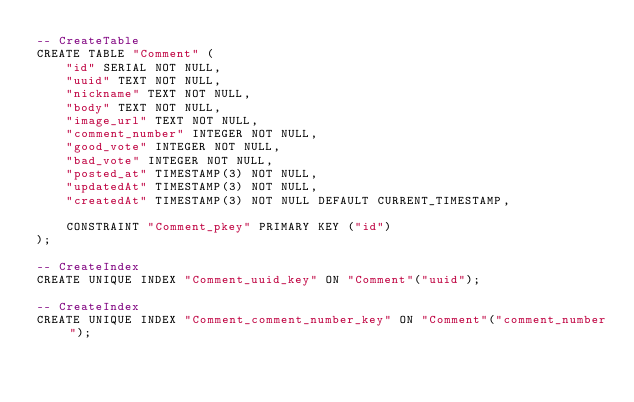Convert code to text. <code><loc_0><loc_0><loc_500><loc_500><_SQL_>-- CreateTable
CREATE TABLE "Comment" (
    "id" SERIAL NOT NULL,
    "uuid" TEXT NOT NULL,
    "nickname" TEXT NOT NULL,
    "body" TEXT NOT NULL,
    "image_url" TEXT NOT NULL,
    "comment_number" INTEGER NOT NULL,
    "good_vote" INTEGER NOT NULL,
    "bad_vote" INTEGER NOT NULL,
    "posted_at" TIMESTAMP(3) NOT NULL,
    "updatedAt" TIMESTAMP(3) NOT NULL,
    "createdAt" TIMESTAMP(3) NOT NULL DEFAULT CURRENT_TIMESTAMP,

    CONSTRAINT "Comment_pkey" PRIMARY KEY ("id")
);

-- CreateIndex
CREATE UNIQUE INDEX "Comment_uuid_key" ON "Comment"("uuid");

-- CreateIndex
CREATE UNIQUE INDEX "Comment_comment_number_key" ON "Comment"("comment_number");
</code> 